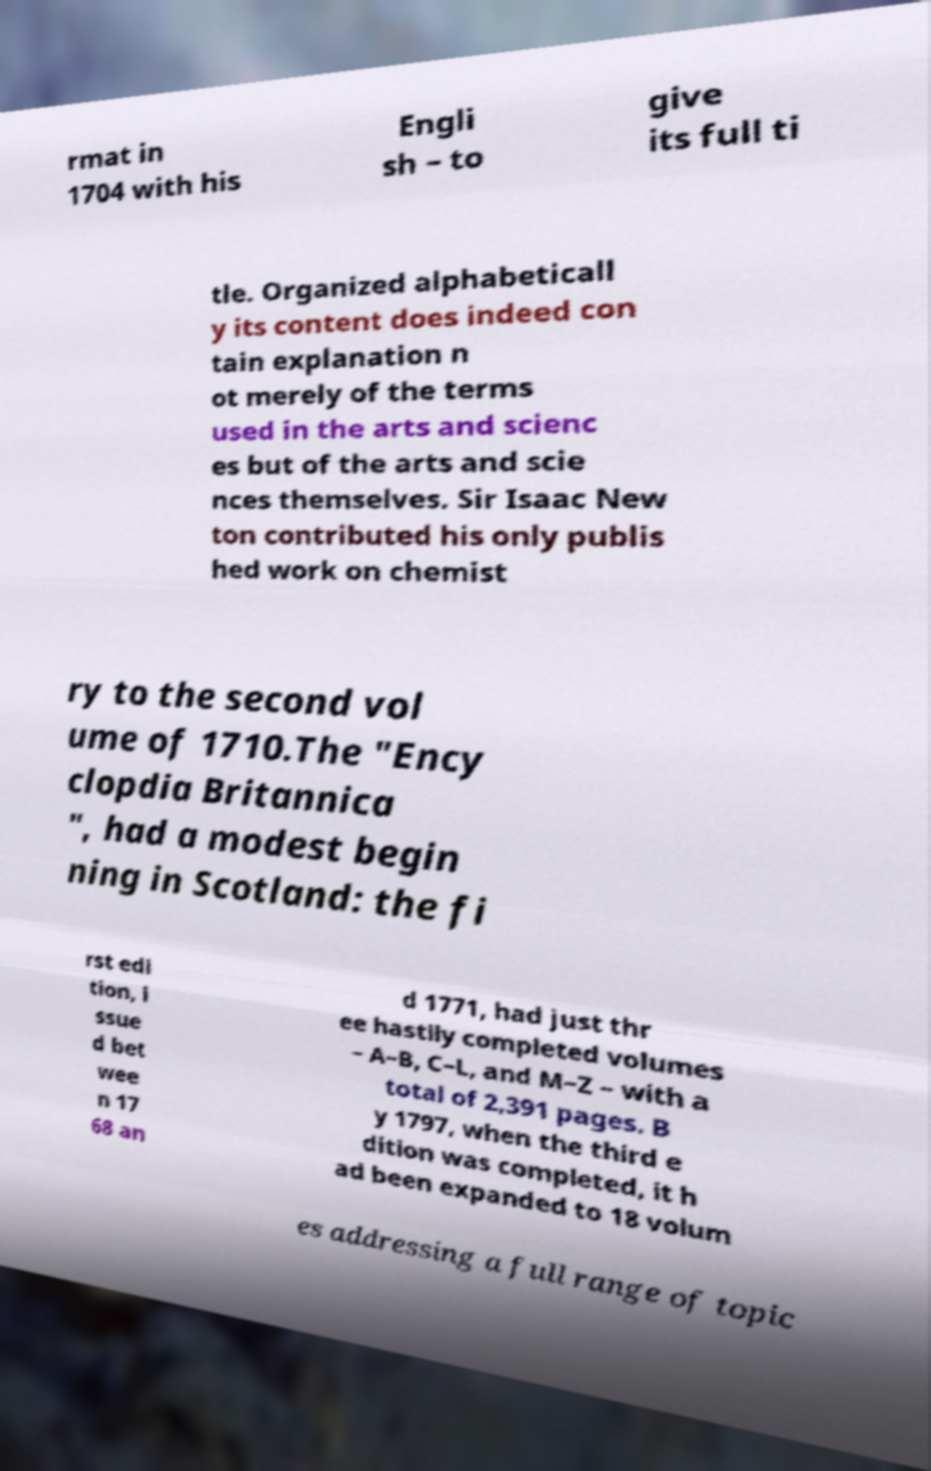Please read and relay the text visible in this image. What does it say? rmat in 1704 with his Engli sh – to give its full ti tle. Organized alphabeticall y its content does indeed con tain explanation n ot merely of the terms used in the arts and scienc es but of the arts and scie nces themselves. Sir Isaac New ton contributed his only publis hed work on chemist ry to the second vol ume of 1710.The "Ency clopdia Britannica ", had a modest begin ning in Scotland: the fi rst edi tion, i ssue d bet wee n 17 68 an d 1771, had just thr ee hastily completed volumes – A–B, C–L, and M–Z – with a total of 2,391 pages. B y 1797, when the third e dition was completed, it h ad been expanded to 18 volum es addressing a full range of topic 